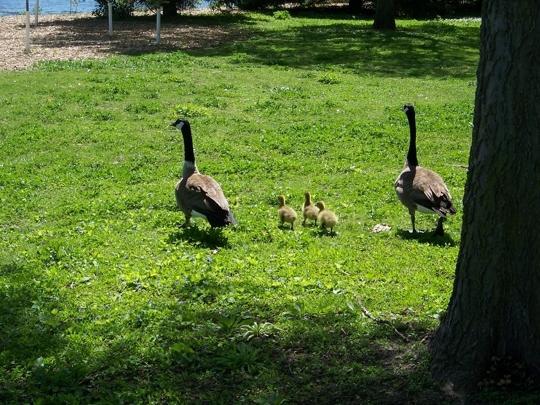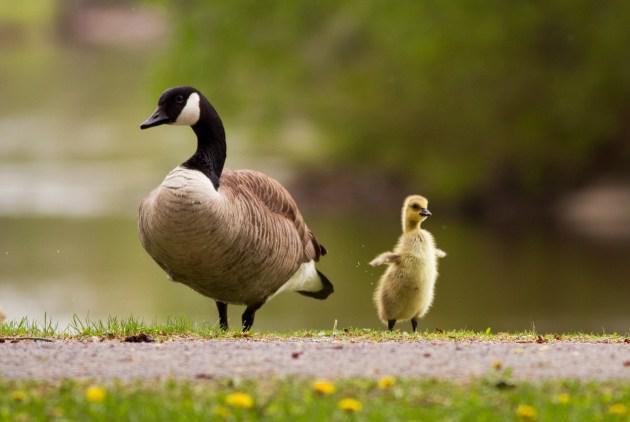The first image is the image on the left, the second image is the image on the right. Considering the images on both sides, is "There is a person near the birds in one of the images." valid? Answer yes or no. No. The first image is the image on the left, the second image is the image on the right. Considering the images on both sides, is "There is a man among a flock of geese in an outdoor setting" valid? Answer yes or no. No. 